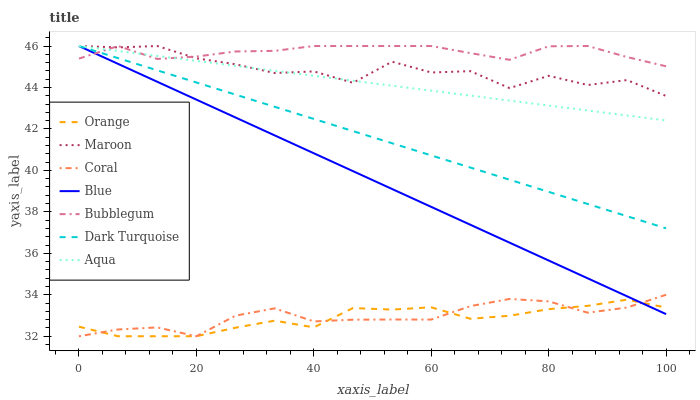Does Orange have the minimum area under the curve?
Answer yes or no. Yes. Does Bubblegum have the maximum area under the curve?
Answer yes or no. Yes. Does Dark Turquoise have the minimum area under the curve?
Answer yes or no. No. Does Dark Turquoise have the maximum area under the curve?
Answer yes or no. No. Is Blue the smoothest?
Answer yes or no. Yes. Is Maroon the roughest?
Answer yes or no. Yes. Is Dark Turquoise the smoothest?
Answer yes or no. No. Is Dark Turquoise the roughest?
Answer yes or no. No. Does Coral have the lowest value?
Answer yes or no. Yes. Does Dark Turquoise have the lowest value?
Answer yes or no. No. Does Maroon have the highest value?
Answer yes or no. Yes. Does Coral have the highest value?
Answer yes or no. No. Is Orange less than Maroon?
Answer yes or no. Yes. Is Dark Turquoise greater than Orange?
Answer yes or no. Yes. Does Bubblegum intersect Blue?
Answer yes or no. Yes. Is Bubblegum less than Blue?
Answer yes or no. No. Is Bubblegum greater than Blue?
Answer yes or no. No. Does Orange intersect Maroon?
Answer yes or no. No. 